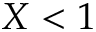Convert formula to latex. <formula><loc_0><loc_0><loc_500><loc_500>X < 1</formula> 